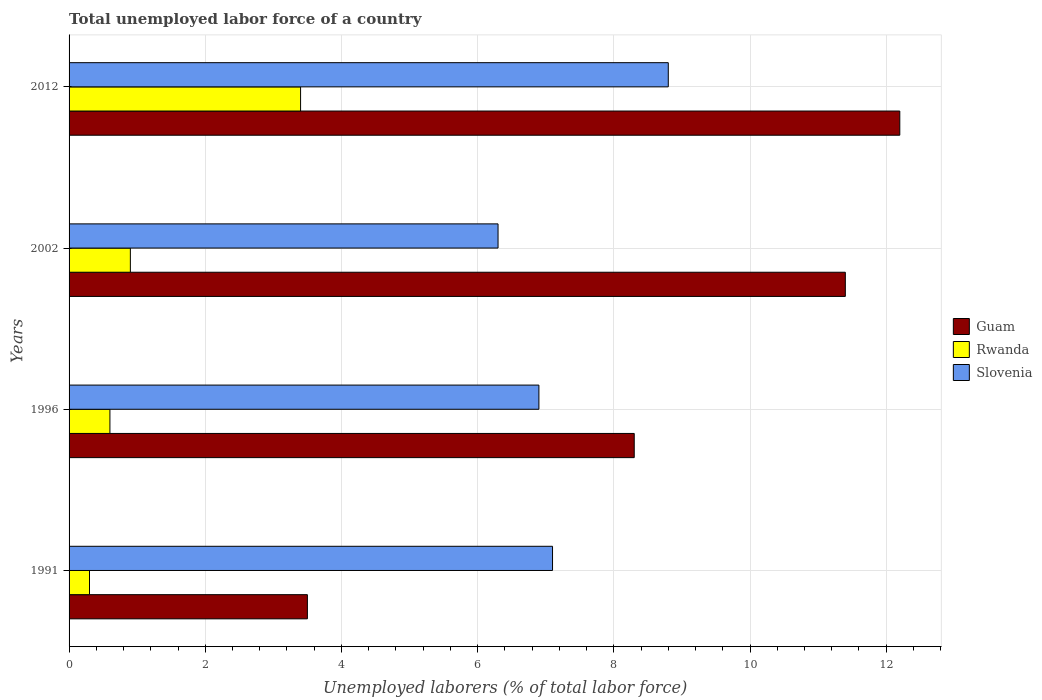How many different coloured bars are there?
Your response must be concise. 3. How many groups of bars are there?
Your response must be concise. 4. Are the number of bars per tick equal to the number of legend labels?
Offer a very short reply. Yes. Are the number of bars on each tick of the Y-axis equal?
Keep it short and to the point. Yes. How many bars are there on the 2nd tick from the top?
Give a very brief answer. 3. How many bars are there on the 4th tick from the bottom?
Keep it short and to the point. 3. What is the label of the 3rd group of bars from the top?
Keep it short and to the point. 1996. What is the total unemployed labor force in Rwanda in 2012?
Your answer should be very brief. 3.4. Across all years, what is the maximum total unemployed labor force in Slovenia?
Your answer should be very brief. 8.8. Across all years, what is the minimum total unemployed labor force in Rwanda?
Make the answer very short. 0.3. What is the total total unemployed labor force in Slovenia in the graph?
Make the answer very short. 29.1. What is the difference between the total unemployed labor force in Rwanda in 1991 and that in 2012?
Provide a succinct answer. -3.1. What is the difference between the total unemployed labor force in Rwanda in 2002 and the total unemployed labor force in Guam in 2012?
Provide a succinct answer. -11.3. What is the average total unemployed labor force in Rwanda per year?
Ensure brevity in your answer.  1.3. In the year 2012, what is the difference between the total unemployed labor force in Rwanda and total unemployed labor force in Slovenia?
Offer a very short reply. -5.4. What is the ratio of the total unemployed labor force in Rwanda in 1991 to that in 1996?
Provide a succinct answer. 0.5. Is the total unemployed labor force in Rwanda in 1996 less than that in 2012?
Provide a succinct answer. Yes. What is the difference between the highest and the second highest total unemployed labor force in Rwanda?
Offer a very short reply. 2.5. What is the difference between the highest and the lowest total unemployed labor force in Slovenia?
Offer a very short reply. 2.5. Is the sum of the total unemployed labor force in Slovenia in 1991 and 2002 greater than the maximum total unemployed labor force in Guam across all years?
Keep it short and to the point. Yes. What does the 3rd bar from the top in 1996 represents?
Keep it short and to the point. Guam. What does the 1st bar from the bottom in 1991 represents?
Provide a succinct answer. Guam. Is it the case that in every year, the sum of the total unemployed labor force in Guam and total unemployed labor force in Slovenia is greater than the total unemployed labor force in Rwanda?
Offer a terse response. Yes. How many bars are there?
Your answer should be very brief. 12. Are all the bars in the graph horizontal?
Offer a very short reply. Yes. How many years are there in the graph?
Your answer should be very brief. 4. Are the values on the major ticks of X-axis written in scientific E-notation?
Your answer should be compact. No. Does the graph contain any zero values?
Your response must be concise. No. How many legend labels are there?
Make the answer very short. 3. How are the legend labels stacked?
Offer a terse response. Vertical. What is the title of the graph?
Your response must be concise. Total unemployed labor force of a country. Does "Sint Maarten (Dutch part)" appear as one of the legend labels in the graph?
Provide a succinct answer. No. What is the label or title of the X-axis?
Provide a succinct answer. Unemployed laborers (% of total labor force). What is the label or title of the Y-axis?
Keep it short and to the point. Years. What is the Unemployed laborers (% of total labor force) of Rwanda in 1991?
Offer a very short reply. 0.3. What is the Unemployed laborers (% of total labor force) of Slovenia in 1991?
Provide a short and direct response. 7.1. What is the Unemployed laborers (% of total labor force) in Guam in 1996?
Give a very brief answer. 8.3. What is the Unemployed laborers (% of total labor force) in Rwanda in 1996?
Keep it short and to the point. 0.6. What is the Unemployed laborers (% of total labor force) in Slovenia in 1996?
Make the answer very short. 6.9. What is the Unemployed laborers (% of total labor force) of Guam in 2002?
Offer a very short reply. 11.4. What is the Unemployed laborers (% of total labor force) in Rwanda in 2002?
Make the answer very short. 0.9. What is the Unemployed laborers (% of total labor force) in Slovenia in 2002?
Provide a succinct answer. 6.3. What is the Unemployed laborers (% of total labor force) in Guam in 2012?
Your answer should be very brief. 12.2. What is the Unemployed laborers (% of total labor force) of Rwanda in 2012?
Your answer should be very brief. 3.4. What is the Unemployed laborers (% of total labor force) of Slovenia in 2012?
Make the answer very short. 8.8. Across all years, what is the maximum Unemployed laborers (% of total labor force) of Guam?
Offer a very short reply. 12.2. Across all years, what is the maximum Unemployed laborers (% of total labor force) of Rwanda?
Your answer should be very brief. 3.4. Across all years, what is the maximum Unemployed laborers (% of total labor force) of Slovenia?
Keep it short and to the point. 8.8. Across all years, what is the minimum Unemployed laborers (% of total labor force) of Guam?
Provide a short and direct response. 3.5. Across all years, what is the minimum Unemployed laborers (% of total labor force) of Rwanda?
Your response must be concise. 0.3. Across all years, what is the minimum Unemployed laborers (% of total labor force) in Slovenia?
Your response must be concise. 6.3. What is the total Unemployed laborers (% of total labor force) of Guam in the graph?
Offer a terse response. 35.4. What is the total Unemployed laborers (% of total labor force) of Rwanda in the graph?
Make the answer very short. 5.2. What is the total Unemployed laborers (% of total labor force) in Slovenia in the graph?
Provide a short and direct response. 29.1. What is the difference between the Unemployed laborers (% of total labor force) in Guam in 1991 and that in 1996?
Give a very brief answer. -4.8. What is the difference between the Unemployed laborers (% of total labor force) of Rwanda in 1991 and that in 1996?
Your response must be concise. -0.3. What is the difference between the Unemployed laborers (% of total labor force) of Guam in 1991 and that in 2002?
Ensure brevity in your answer.  -7.9. What is the difference between the Unemployed laborers (% of total labor force) in Rwanda in 1991 and that in 2002?
Provide a short and direct response. -0.6. What is the difference between the Unemployed laborers (% of total labor force) of Guam in 1991 and that in 2012?
Provide a short and direct response. -8.7. What is the difference between the Unemployed laborers (% of total labor force) in Rwanda in 1991 and that in 2012?
Your answer should be compact. -3.1. What is the difference between the Unemployed laborers (% of total labor force) in Slovenia in 1991 and that in 2012?
Provide a succinct answer. -1.7. What is the difference between the Unemployed laborers (% of total labor force) in Slovenia in 1996 and that in 2002?
Offer a very short reply. 0.6. What is the difference between the Unemployed laborers (% of total labor force) in Guam in 1996 and that in 2012?
Your response must be concise. -3.9. What is the difference between the Unemployed laborers (% of total labor force) in Rwanda in 1996 and that in 2012?
Provide a short and direct response. -2.8. What is the difference between the Unemployed laborers (% of total labor force) in Guam in 2002 and that in 2012?
Provide a short and direct response. -0.8. What is the difference between the Unemployed laborers (% of total labor force) in Rwanda in 2002 and that in 2012?
Your response must be concise. -2.5. What is the difference between the Unemployed laborers (% of total labor force) of Slovenia in 2002 and that in 2012?
Make the answer very short. -2.5. What is the difference between the Unemployed laborers (% of total labor force) in Guam in 1991 and the Unemployed laborers (% of total labor force) in Slovenia in 1996?
Give a very brief answer. -3.4. What is the difference between the Unemployed laborers (% of total labor force) in Rwanda in 1991 and the Unemployed laborers (% of total labor force) in Slovenia in 1996?
Provide a succinct answer. -6.6. What is the difference between the Unemployed laborers (% of total labor force) of Guam in 1991 and the Unemployed laborers (% of total labor force) of Slovenia in 2002?
Make the answer very short. -2.8. What is the difference between the Unemployed laborers (% of total labor force) in Rwanda in 1991 and the Unemployed laborers (% of total labor force) in Slovenia in 2002?
Provide a short and direct response. -6. What is the difference between the Unemployed laborers (% of total labor force) in Guam in 1996 and the Unemployed laborers (% of total labor force) in Rwanda in 2002?
Give a very brief answer. 7.4. What is the difference between the Unemployed laborers (% of total labor force) in Guam in 1996 and the Unemployed laborers (% of total labor force) in Slovenia in 2002?
Give a very brief answer. 2. What is the difference between the Unemployed laborers (% of total labor force) in Guam in 1996 and the Unemployed laborers (% of total labor force) in Slovenia in 2012?
Offer a very short reply. -0.5. What is the difference between the Unemployed laborers (% of total labor force) of Rwanda in 1996 and the Unemployed laborers (% of total labor force) of Slovenia in 2012?
Your answer should be very brief. -8.2. What is the difference between the Unemployed laborers (% of total labor force) in Guam in 2002 and the Unemployed laborers (% of total labor force) in Rwanda in 2012?
Provide a short and direct response. 8. What is the difference between the Unemployed laborers (% of total labor force) of Guam in 2002 and the Unemployed laborers (% of total labor force) of Slovenia in 2012?
Your answer should be very brief. 2.6. What is the difference between the Unemployed laborers (% of total labor force) of Rwanda in 2002 and the Unemployed laborers (% of total labor force) of Slovenia in 2012?
Your answer should be very brief. -7.9. What is the average Unemployed laborers (% of total labor force) in Guam per year?
Give a very brief answer. 8.85. What is the average Unemployed laborers (% of total labor force) in Rwanda per year?
Offer a terse response. 1.3. What is the average Unemployed laborers (% of total labor force) in Slovenia per year?
Provide a short and direct response. 7.28. In the year 1991, what is the difference between the Unemployed laborers (% of total labor force) in Guam and Unemployed laborers (% of total labor force) in Slovenia?
Your answer should be very brief. -3.6. In the year 1996, what is the difference between the Unemployed laborers (% of total labor force) in Guam and Unemployed laborers (% of total labor force) in Rwanda?
Your response must be concise. 7.7. In the year 1996, what is the difference between the Unemployed laborers (% of total labor force) in Guam and Unemployed laborers (% of total labor force) in Slovenia?
Your response must be concise. 1.4. In the year 2002, what is the difference between the Unemployed laborers (% of total labor force) in Rwanda and Unemployed laborers (% of total labor force) in Slovenia?
Offer a terse response. -5.4. In the year 2012, what is the difference between the Unemployed laborers (% of total labor force) of Rwanda and Unemployed laborers (% of total labor force) of Slovenia?
Give a very brief answer. -5.4. What is the ratio of the Unemployed laborers (% of total labor force) of Guam in 1991 to that in 1996?
Provide a succinct answer. 0.42. What is the ratio of the Unemployed laborers (% of total labor force) of Rwanda in 1991 to that in 1996?
Ensure brevity in your answer.  0.5. What is the ratio of the Unemployed laborers (% of total labor force) in Slovenia in 1991 to that in 1996?
Offer a very short reply. 1.03. What is the ratio of the Unemployed laborers (% of total labor force) in Guam in 1991 to that in 2002?
Your answer should be compact. 0.31. What is the ratio of the Unemployed laborers (% of total labor force) of Slovenia in 1991 to that in 2002?
Make the answer very short. 1.13. What is the ratio of the Unemployed laborers (% of total labor force) in Guam in 1991 to that in 2012?
Give a very brief answer. 0.29. What is the ratio of the Unemployed laborers (% of total labor force) of Rwanda in 1991 to that in 2012?
Your answer should be very brief. 0.09. What is the ratio of the Unemployed laborers (% of total labor force) of Slovenia in 1991 to that in 2012?
Make the answer very short. 0.81. What is the ratio of the Unemployed laborers (% of total labor force) of Guam in 1996 to that in 2002?
Offer a very short reply. 0.73. What is the ratio of the Unemployed laborers (% of total labor force) in Rwanda in 1996 to that in 2002?
Your response must be concise. 0.67. What is the ratio of the Unemployed laborers (% of total labor force) in Slovenia in 1996 to that in 2002?
Offer a terse response. 1.1. What is the ratio of the Unemployed laborers (% of total labor force) of Guam in 1996 to that in 2012?
Your answer should be very brief. 0.68. What is the ratio of the Unemployed laborers (% of total labor force) of Rwanda in 1996 to that in 2012?
Your answer should be very brief. 0.18. What is the ratio of the Unemployed laborers (% of total labor force) of Slovenia in 1996 to that in 2012?
Make the answer very short. 0.78. What is the ratio of the Unemployed laborers (% of total labor force) of Guam in 2002 to that in 2012?
Offer a terse response. 0.93. What is the ratio of the Unemployed laborers (% of total labor force) in Rwanda in 2002 to that in 2012?
Your answer should be very brief. 0.26. What is the ratio of the Unemployed laborers (% of total labor force) of Slovenia in 2002 to that in 2012?
Your answer should be compact. 0.72. What is the difference between the highest and the second highest Unemployed laborers (% of total labor force) in Rwanda?
Your answer should be very brief. 2.5. What is the difference between the highest and the second highest Unemployed laborers (% of total labor force) of Slovenia?
Make the answer very short. 1.7. What is the difference between the highest and the lowest Unemployed laborers (% of total labor force) in Guam?
Your answer should be very brief. 8.7. What is the difference between the highest and the lowest Unemployed laborers (% of total labor force) in Rwanda?
Provide a succinct answer. 3.1. 